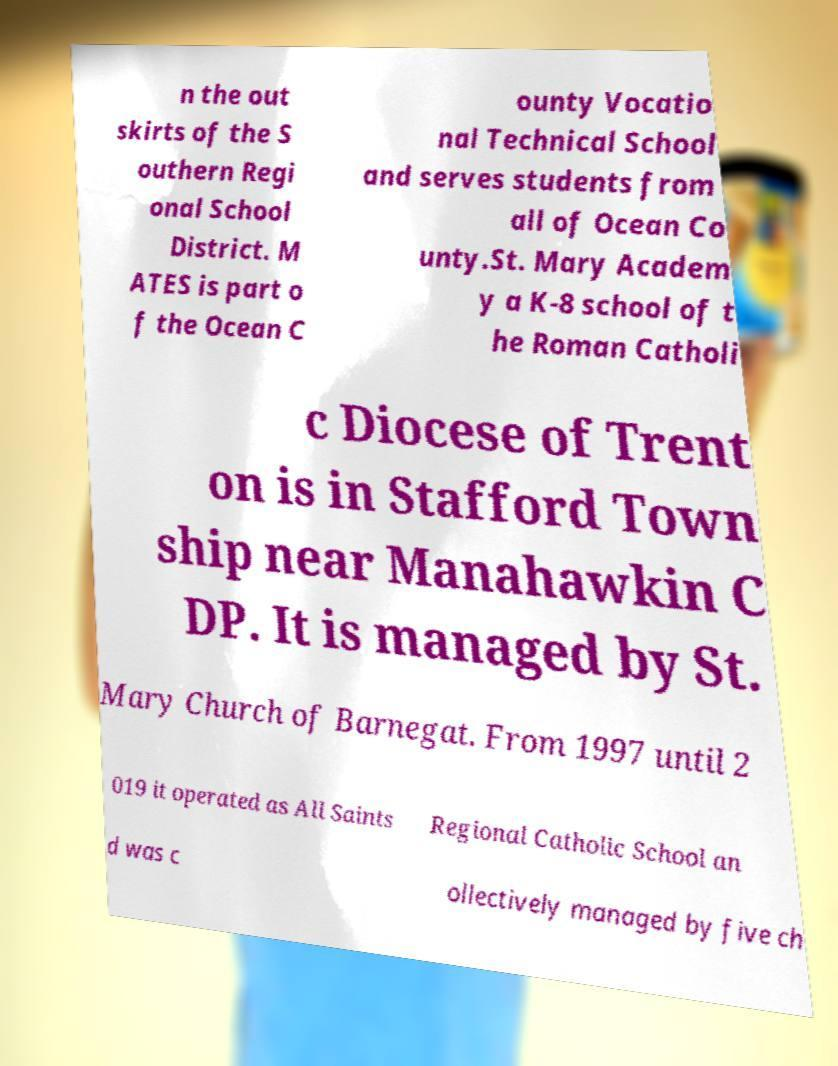Can you accurately transcribe the text from the provided image for me? n the out skirts of the S outhern Regi onal School District. M ATES is part o f the Ocean C ounty Vocatio nal Technical School and serves students from all of Ocean Co unty.St. Mary Academ y a K-8 school of t he Roman Catholi c Diocese of Trent on is in Stafford Town ship near Manahawkin C DP. It is managed by St. Mary Church of Barnegat. From 1997 until 2 019 it operated as All Saints Regional Catholic School an d was c ollectively managed by five ch 